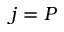Convert formula to latex. <formula><loc_0><loc_0><loc_500><loc_500>j = P</formula> 